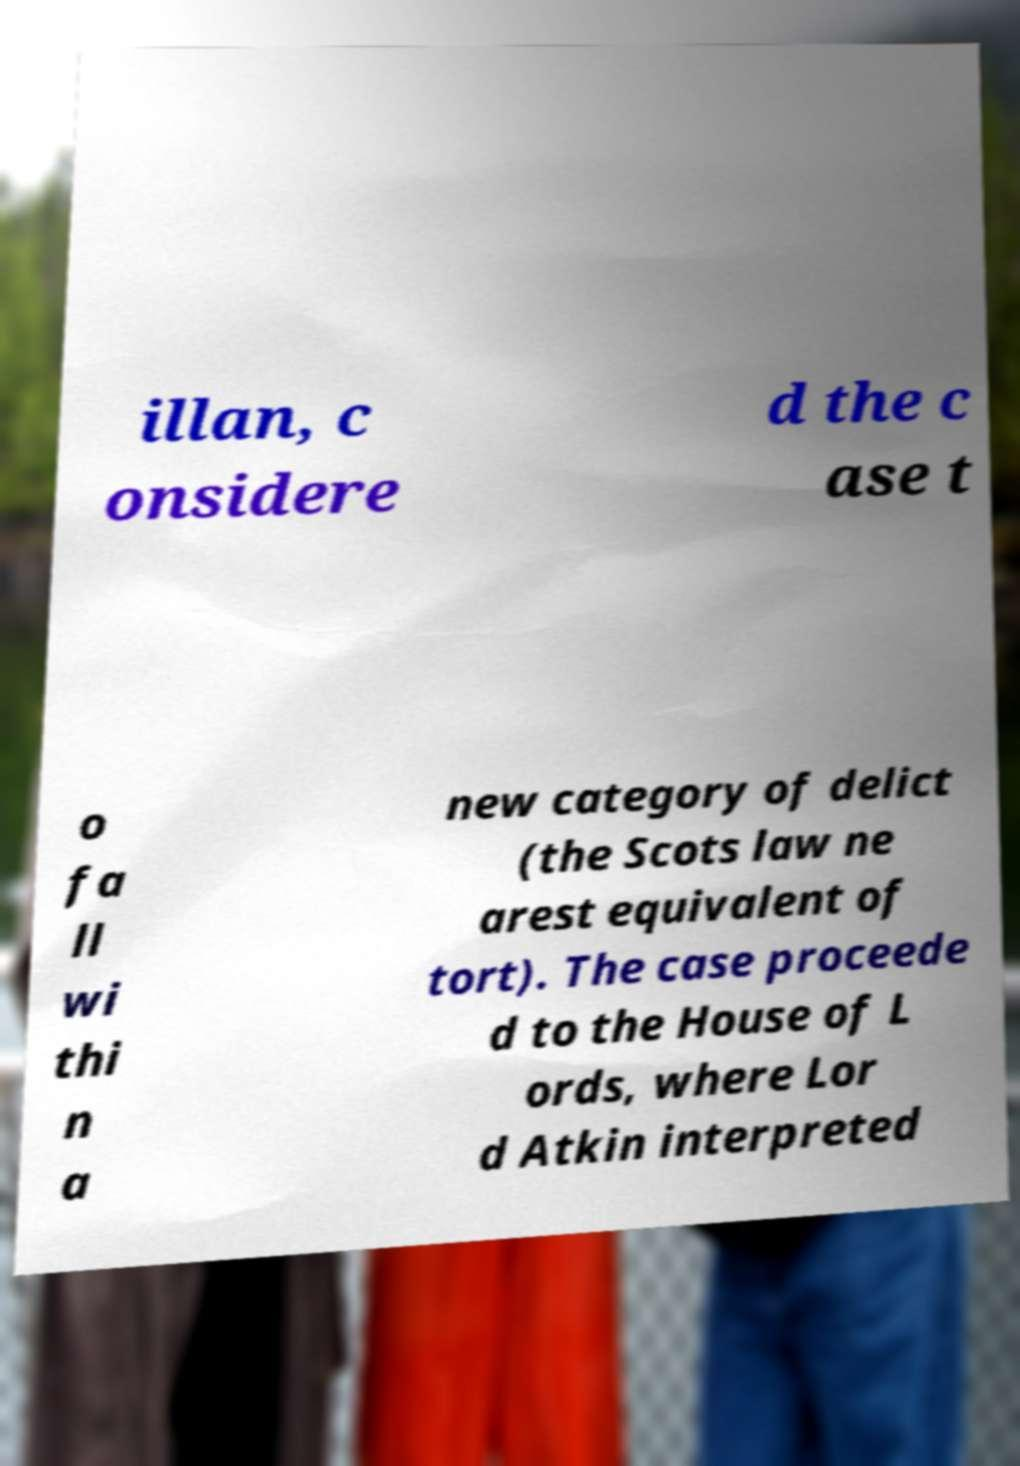Can you accurately transcribe the text from the provided image for me? illan, c onsidere d the c ase t o fa ll wi thi n a new category of delict (the Scots law ne arest equivalent of tort). The case proceede d to the House of L ords, where Lor d Atkin interpreted 